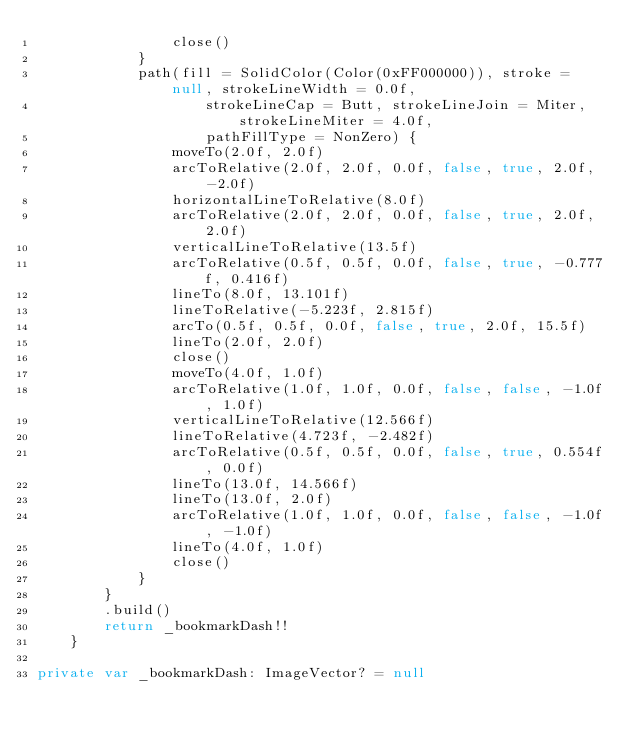<code> <loc_0><loc_0><loc_500><loc_500><_Kotlin_>                close()
            }
            path(fill = SolidColor(Color(0xFF000000)), stroke = null, strokeLineWidth = 0.0f,
                    strokeLineCap = Butt, strokeLineJoin = Miter, strokeLineMiter = 4.0f,
                    pathFillType = NonZero) {
                moveTo(2.0f, 2.0f)
                arcToRelative(2.0f, 2.0f, 0.0f, false, true, 2.0f, -2.0f)
                horizontalLineToRelative(8.0f)
                arcToRelative(2.0f, 2.0f, 0.0f, false, true, 2.0f, 2.0f)
                verticalLineToRelative(13.5f)
                arcToRelative(0.5f, 0.5f, 0.0f, false, true, -0.777f, 0.416f)
                lineTo(8.0f, 13.101f)
                lineToRelative(-5.223f, 2.815f)
                arcTo(0.5f, 0.5f, 0.0f, false, true, 2.0f, 15.5f)
                lineTo(2.0f, 2.0f)
                close()
                moveTo(4.0f, 1.0f)
                arcToRelative(1.0f, 1.0f, 0.0f, false, false, -1.0f, 1.0f)
                verticalLineToRelative(12.566f)
                lineToRelative(4.723f, -2.482f)
                arcToRelative(0.5f, 0.5f, 0.0f, false, true, 0.554f, 0.0f)
                lineTo(13.0f, 14.566f)
                lineTo(13.0f, 2.0f)
                arcToRelative(1.0f, 1.0f, 0.0f, false, false, -1.0f, -1.0f)
                lineTo(4.0f, 1.0f)
                close()
            }
        }
        .build()
        return _bookmarkDash!!
    }

private var _bookmarkDash: ImageVector? = null
</code> 